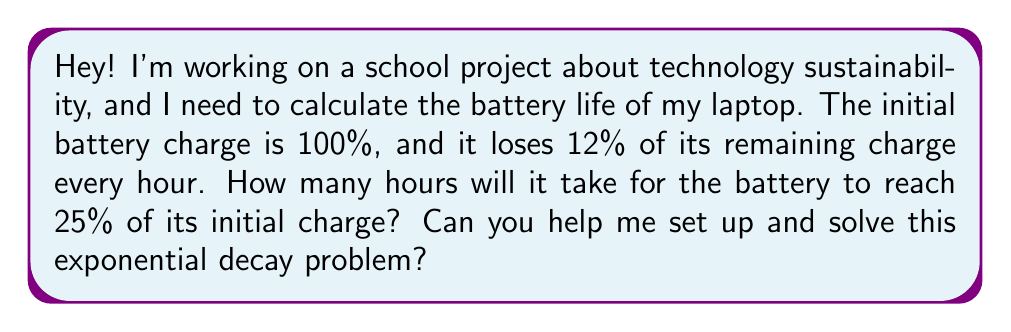Provide a solution to this math problem. Sure! Let's break this down step-by-step:

1) First, we need to set up our exponential decay equation. The general form is:

   $A(t) = A_0 \cdot (1-r)^t$

   Where:
   $A(t)$ is the amount remaining after time $t$
   $A_0$ is the initial amount
   $r$ is the decay rate per unit time
   $t$ is the time

2) In this case:
   $A_0 = 100\%$ (initial charge)
   $r = 12\% = 0.12$ (decay rate per hour)
   We want to find $t$ when $A(t) = 25\%$

3) Let's plug these into our equation:

   $25 = 100 \cdot (1-0.12)^t$

4) Simplify:

   $0.25 = (0.88)^t$

5) To solve for $t$, we need to use logarithms. Let's apply $\ln$ to both sides:

   $\ln(0.25) = \ln((0.88)^t)$

6) Using the logarithm property $\ln(a^b) = b\ln(a)$:

   $\ln(0.25) = t \cdot \ln(0.88)$

7) Now we can solve for $t$:

   $t = \frac{\ln(0.25)}{\ln(0.88)}$

8) Use a calculator to evaluate:

   $t \approx 11.28$ hours
Answer: It will take approximately 11.28 hours for the battery to reach 25% of its initial charge. 